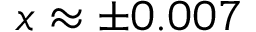Convert formula to latex. <formula><loc_0><loc_0><loc_500><loc_500>x \approx \pm 0 . 0 0 7</formula> 